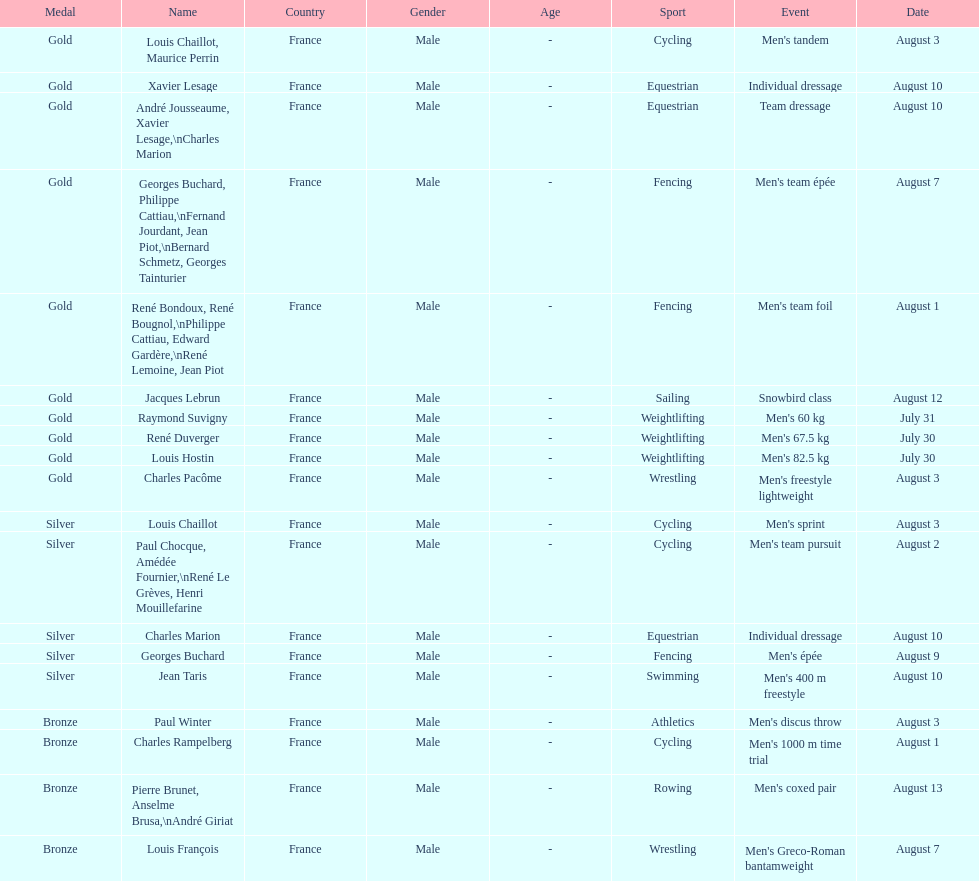How many total gold medals were won by weightlifting? 3. 